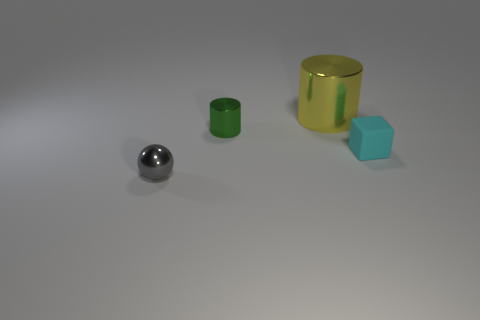Add 1 yellow metallic objects. How many objects exist? 5 Subtract all blocks. How many objects are left? 3 Subtract all objects. Subtract all yellow rubber balls. How many objects are left? 0 Add 1 tiny gray balls. How many tiny gray balls are left? 2 Add 3 tiny cyan rubber blocks. How many tiny cyan rubber blocks exist? 4 Subtract 1 gray spheres. How many objects are left? 3 